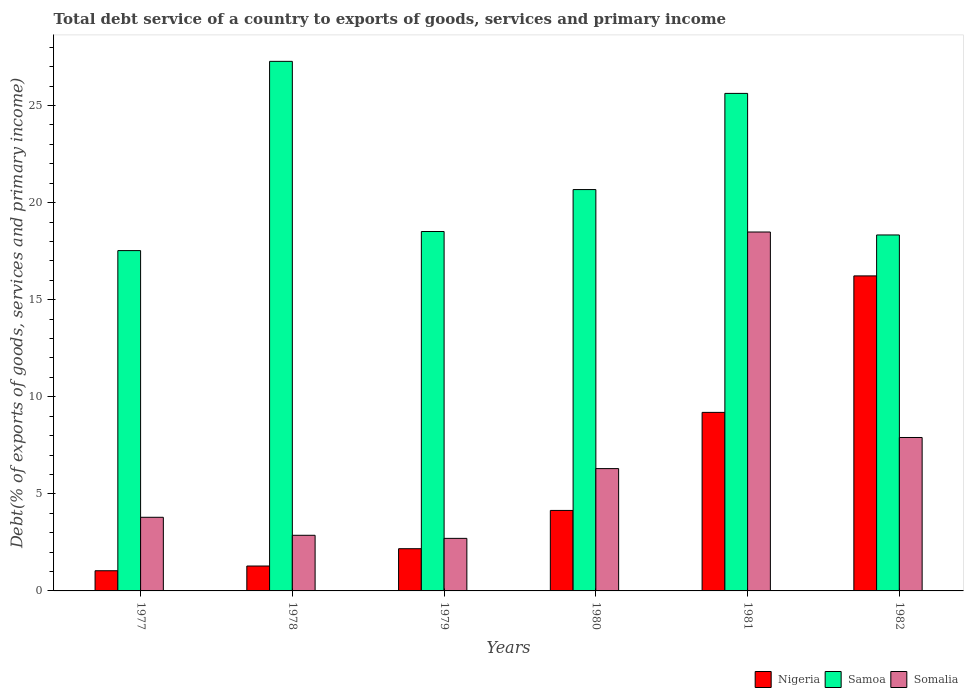How many groups of bars are there?
Provide a short and direct response. 6. Are the number of bars per tick equal to the number of legend labels?
Ensure brevity in your answer.  Yes. Are the number of bars on each tick of the X-axis equal?
Make the answer very short. Yes. How many bars are there on the 5th tick from the left?
Give a very brief answer. 3. How many bars are there on the 3rd tick from the right?
Your answer should be compact. 3. What is the total debt service in Samoa in 1979?
Ensure brevity in your answer.  18.51. Across all years, what is the maximum total debt service in Samoa?
Keep it short and to the point. 27.28. Across all years, what is the minimum total debt service in Nigeria?
Give a very brief answer. 1.04. In which year was the total debt service in Samoa maximum?
Offer a terse response. 1978. In which year was the total debt service in Nigeria minimum?
Your response must be concise. 1977. What is the total total debt service in Somalia in the graph?
Your answer should be very brief. 42.06. What is the difference between the total debt service in Somalia in 1977 and that in 1979?
Keep it short and to the point. 1.09. What is the difference between the total debt service in Nigeria in 1982 and the total debt service in Somalia in 1978?
Give a very brief answer. 13.36. What is the average total debt service in Nigeria per year?
Offer a terse response. 5.68. In the year 1982, what is the difference between the total debt service in Nigeria and total debt service in Somalia?
Your answer should be compact. 8.32. What is the ratio of the total debt service in Samoa in 1977 to that in 1978?
Make the answer very short. 0.64. Is the difference between the total debt service in Nigeria in 1977 and 1981 greater than the difference between the total debt service in Somalia in 1977 and 1981?
Provide a short and direct response. Yes. What is the difference between the highest and the second highest total debt service in Somalia?
Offer a terse response. 10.58. What is the difference between the highest and the lowest total debt service in Samoa?
Make the answer very short. 9.75. In how many years, is the total debt service in Nigeria greater than the average total debt service in Nigeria taken over all years?
Keep it short and to the point. 2. What does the 3rd bar from the left in 1982 represents?
Your response must be concise. Somalia. What does the 2nd bar from the right in 1981 represents?
Your answer should be very brief. Samoa. How many bars are there?
Keep it short and to the point. 18. Are all the bars in the graph horizontal?
Provide a short and direct response. No. How many years are there in the graph?
Provide a short and direct response. 6. What is the difference between two consecutive major ticks on the Y-axis?
Your response must be concise. 5. Does the graph contain grids?
Your response must be concise. No. What is the title of the graph?
Provide a short and direct response. Total debt service of a country to exports of goods, services and primary income. Does "Sweden" appear as one of the legend labels in the graph?
Give a very brief answer. No. What is the label or title of the Y-axis?
Provide a short and direct response. Debt(% of exports of goods, services and primary income). What is the Debt(% of exports of goods, services and primary income) in Nigeria in 1977?
Make the answer very short. 1.04. What is the Debt(% of exports of goods, services and primary income) of Samoa in 1977?
Give a very brief answer. 17.53. What is the Debt(% of exports of goods, services and primary income) of Somalia in 1977?
Ensure brevity in your answer.  3.79. What is the Debt(% of exports of goods, services and primary income) of Nigeria in 1978?
Give a very brief answer. 1.28. What is the Debt(% of exports of goods, services and primary income) in Samoa in 1978?
Your answer should be compact. 27.28. What is the Debt(% of exports of goods, services and primary income) of Somalia in 1978?
Provide a succinct answer. 2.87. What is the Debt(% of exports of goods, services and primary income) of Nigeria in 1979?
Your answer should be compact. 2.17. What is the Debt(% of exports of goods, services and primary income) of Samoa in 1979?
Give a very brief answer. 18.51. What is the Debt(% of exports of goods, services and primary income) in Somalia in 1979?
Make the answer very short. 2.71. What is the Debt(% of exports of goods, services and primary income) of Nigeria in 1980?
Give a very brief answer. 4.15. What is the Debt(% of exports of goods, services and primary income) of Samoa in 1980?
Your answer should be very brief. 20.67. What is the Debt(% of exports of goods, services and primary income) of Somalia in 1980?
Your answer should be compact. 6.3. What is the Debt(% of exports of goods, services and primary income) in Nigeria in 1981?
Your answer should be very brief. 9.2. What is the Debt(% of exports of goods, services and primary income) of Samoa in 1981?
Offer a terse response. 25.63. What is the Debt(% of exports of goods, services and primary income) in Somalia in 1981?
Provide a short and direct response. 18.49. What is the Debt(% of exports of goods, services and primary income) in Nigeria in 1982?
Your response must be concise. 16.23. What is the Debt(% of exports of goods, services and primary income) of Samoa in 1982?
Keep it short and to the point. 18.33. What is the Debt(% of exports of goods, services and primary income) in Somalia in 1982?
Make the answer very short. 7.9. Across all years, what is the maximum Debt(% of exports of goods, services and primary income) in Nigeria?
Give a very brief answer. 16.23. Across all years, what is the maximum Debt(% of exports of goods, services and primary income) of Samoa?
Your answer should be compact. 27.28. Across all years, what is the maximum Debt(% of exports of goods, services and primary income) in Somalia?
Offer a terse response. 18.49. Across all years, what is the minimum Debt(% of exports of goods, services and primary income) in Nigeria?
Offer a very short reply. 1.04. Across all years, what is the minimum Debt(% of exports of goods, services and primary income) in Samoa?
Keep it short and to the point. 17.53. Across all years, what is the minimum Debt(% of exports of goods, services and primary income) in Somalia?
Give a very brief answer. 2.71. What is the total Debt(% of exports of goods, services and primary income) in Nigeria in the graph?
Your answer should be compact. 34.06. What is the total Debt(% of exports of goods, services and primary income) of Samoa in the graph?
Make the answer very short. 127.95. What is the total Debt(% of exports of goods, services and primary income) in Somalia in the graph?
Your answer should be very brief. 42.06. What is the difference between the Debt(% of exports of goods, services and primary income) in Nigeria in 1977 and that in 1978?
Your response must be concise. -0.24. What is the difference between the Debt(% of exports of goods, services and primary income) of Samoa in 1977 and that in 1978?
Your answer should be compact. -9.75. What is the difference between the Debt(% of exports of goods, services and primary income) in Somalia in 1977 and that in 1978?
Give a very brief answer. 0.93. What is the difference between the Debt(% of exports of goods, services and primary income) in Nigeria in 1977 and that in 1979?
Your answer should be very brief. -1.13. What is the difference between the Debt(% of exports of goods, services and primary income) in Samoa in 1977 and that in 1979?
Offer a terse response. -0.98. What is the difference between the Debt(% of exports of goods, services and primary income) in Somalia in 1977 and that in 1979?
Your answer should be compact. 1.09. What is the difference between the Debt(% of exports of goods, services and primary income) in Nigeria in 1977 and that in 1980?
Provide a succinct answer. -3.11. What is the difference between the Debt(% of exports of goods, services and primary income) in Samoa in 1977 and that in 1980?
Provide a short and direct response. -3.14. What is the difference between the Debt(% of exports of goods, services and primary income) in Somalia in 1977 and that in 1980?
Provide a succinct answer. -2.51. What is the difference between the Debt(% of exports of goods, services and primary income) in Nigeria in 1977 and that in 1981?
Provide a succinct answer. -8.16. What is the difference between the Debt(% of exports of goods, services and primary income) in Samoa in 1977 and that in 1981?
Provide a short and direct response. -8.1. What is the difference between the Debt(% of exports of goods, services and primary income) in Somalia in 1977 and that in 1981?
Your answer should be very brief. -14.69. What is the difference between the Debt(% of exports of goods, services and primary income) of Nigeria in 1977 and that in 1982?
Offer a terse response. -15.19. What is the difference between the Debt(% of exports of goods, services and primary income) of Samoa in 1977 and that in 1982?
Provide a succinct answer. -0.81. What is the difference between the Debt(% of exports of goods, services and primary income) of Somalia in 1977 and that in 1982?
Ensure brevity in your answer.  -4.11. What is the difference between the Debt(% of exports of goods, services and primary income) in Nigeria in 1978 and that in 1979?
Make the answer very short. -0.89. What is the difference between the Debt(% of exports of goods, services and primary income) of Samoa in 1978 and that in 1979?
Keep it short and to the point. 8.76. What is the difference between the Debt(% of exports of goods, services and primary income) in Somalia in 1978 and that in 1979?
Provide a succinct answer. 0.16. What is the difference between the Debt(% of exports of goods, services and primary income) in Nigeria in 1978 and that in 1980?
Keep it short and to the point. -2.86. What is the difference between the Debt(% of exports of goods, services and primary income) in Samoa in 1978 and that in 1980?
Keep it short and to the point. 6.6. What is the difference between the Debt(% of exports of goods, services and primary income) of Somalia in 1978 and that in 1980?
Make the answer very short. -3.43. What is the difference between the Debt(% of exports of goods, services and primary income) in Nigeria in 1978 and that in 1981?
Your answer should be very brief. -7.91. What is the difference between the Debt(% of exports of goods, services and primary income) of Samoa in 1978 and that in 1981?
Your answer should be compact. 1.65. What is the difference between the Debt(% of exports of goods, services and primary income) in Somalia in 1978 and that in 1981?
Provide a succinct answer. -15.62. What is the difference between the Debt(% of exports of goods, services and primary income) of Nigeria in 1978 and that in 1982?
Your answer should be very brief. -14.94. What is the difference between the Debt(% of exports of goods, services and primary income) of Samoa in 1978 and that in 1982?
Offer a very short reply. 8.94. What is the difference between the Debt(% of exports of goods, services and primary income) of Somalia in 1978 and that in 1982?
Your answer should be compact. -5.04. What is the difference between the Debt(% of exports of goods, services and primary income) of Nigeria in 1979 and that in 1980?
Your answer should be compact. -1.97. What is the difference between the Debt(% of exports of goods, services and primary income) in Samoa in 1979 and that in 1980?
Your response must be concise. -2.16. What is the difference between the Debt(% of exports of goods, services and primary income) in Somalia in 1979 and that in 1980?
Offer a terse response. -3.59. What is the difference between the Debt(% of exports of goods, services and primary income) of Nigeria in 1979 and that in 1981?
Your response must be concise. -7.02. What is the difference between the Debt(% of exports of goods, services and primary income) in Samoa in 1979 and that in 1981?
Offer a terse response. -7.11. What is the difference between the Debt(% of exports of goods, services and primary income) of Somalia in 1979 and that in 1981?
Provide a short and direct response. -15.78. What is the difference between the Debt(% of exports of goods, services and primary income) in Nigeria in 1979 and that in 1982?
Make the answer very short. -14.05. What is the difference between the Debt(% of exports of goods, services and primary income) in Samoa in 1979 and that in 1982?
Offer a very short reply. 0.18. What is the difference between the Debt(% of exports of goods, services and primary income) of Somalia in 1979 and that in 1982?
Your answer should be compact. -5.2. What is the difference between the Debt(% of exports of goods, services and primary income) in Nigeria in 1980 and that in 1981?
Keep it short and to the point. -5.05. What is the difference between the Debt(% of exports of goods, services and primary income) in Samoa in 1980 and that in 1981?
Your answer should be compact. -4.95. What is the difference between the Debt(% of exports of goods, services and primary income) in Somalia in 1980 and that in 1981?
Provide a short and direct response. -12.19. What is the difference between the Debt(% of exports of goods, services and primary income) in Nigeria in 1980 and that in 1982?
Your answer should be compact. -12.08. What is the difference between the Debt(% of exports of goods, services and primary income) in Samoa in 1980 and that in 1982?
Make the answer very short. 2.34. What is the difference between the Debt(% of exports of goods, services and primary income) in Somalia in 1980 and that in 1982?
Keep it short and to the point. -1.6. What is the difference between the Debt(% of exports of goods, services and primary income) in Nigeria in 1981 and that in 1982?
Your answer should be very brief. -7.03. What is the difference between the Debt(% of exports of goods, services and primary income) of Samoa in 1981 and that in 1982?
Your response must be concise. 7.29. What is the difference between the Debt(% of exports of goods, services and primary income) of Somalia in 1981 and that in 1982?
Offer a very short reply. 10.58. What is the difference between the Debt(% of exports of goods, services and primary income) of Nigeria in 1977 and the Debt(% of exports of goods, services and primary income) of Samoa in 1978?
Offer a terse response. -26.24. What is the difference between the Debt(% of exports of goods, services and primary income) in Nigeria in 1977 and the Debt(% of exports of goods, services and primary income) in Somalia in 1978?
Provide a short and direct response. -1.83. What is the difference between the Debt(% of exports of goods, services and primary income) in Samoa in 1977 and the Debt(% of exports of goods, services and primary income) in Somalia in 1978?
Give a very brief answer. 14.66. What is the difference between the Debt(% of exports of goods, services and primary income) of Nigeria in 1977 and the Debt(% of exports of goods, services and primary income) of Samoa in 1979?
Give a very brief answer. -17.47. What is the difference between the Debt(% of exports of goods, services and primary income) of Nigeria in 1977 and the Debt(% of exports of goods, services and primary income) of Somalia in 1979?
Offer a very short reply. -1.67. What is the difference between the Debt(% of exports of goods, services and primary income) in Samoa in 1977 and the Debt(% of exports of goods, services and primary income) in Somalia in 1979?
Make the answer very short. 14.82. What is the difference between the Debt(% of exports of goods, services and primary income) of Nigeria in 1977 and the Debt(% of exports of goods, services and primary income) of Samoa in 1980?
Your response must be concise. -19.63. What is the difference between the Debt(% of exports of goods, services and primary income) in Nigeria in 1977 and the Debt(% of exports of goods, services and primary income) in Somalia in 1980?
Give a very brief answer. -5.26. What is the difference between the Debt(% of exports of goods, services and primary income) in Samoa in 1977 and the Debt(% of exports of goods, services and primary income) in Somalia in 1980?
Your response must be concise. 11.23. What is the difference between the Debt(% of exports of goods, services and primary income) of Nigeria in 1977 and the Debt(% of exports of goods, services and primary income) of Samoa in 1981?
Provide a short and direct response. -24.59. What is the difference between the Debt(% of exports of goods, services and primary income) in Nigeria in 1977 and the Debt(% of exports of goods, services and primary income) in Somalia in 1981?
Give a very brief answer. -17.45. What is the difference between the Debt(% of exports of goods, services and primary income) of Samoa in 1977 and the Debt(% of exports of goods, services and primary income) of Somalia in 1981?
Provide a short and direct response. -0.96. What is the difference between the Debt(% of exports of goods, services and primary income) of Nigeria in 1977 and the Debt(% of exports of goods, services and primary income) of Samoa in 1982?
Ensure brevity in your answer.  -17.3. What is the difference between the Debt(% of exports of goods, services and primary income) in Nigeria in 1977 and the Debt(% of exports of goods, services and primary income) in Somalia in 1982?
Provide a short and direct response. -6.86. What is the difference between the Debt(% of exports of goods, services and primary income) in Samoa in 1977 and the Debt(% of exports of goods, services and primary income) in Somalia in 1982?
Your answer should be compact. 9.63. What is the difference between the Debt(% of exports of goods, services and primary income) of Nigeria in 1978 and the Debt(% of exports of goods, services and primary income) of Samoa in 1979?
Offer a very short reply. -17.23. What is the difference between the Debt(% of exports of goods, services and primary income) in Nigeria in 1978 and the Debt(% of exports of goods, services and primary income) in Somalia in 1979?
Provide a short and direct response. -1.42. What is the difference between the Debt(% of exports of goods, services and primary income) of Samoa in 1978 and the Debt(% of exports of goods, services and primary income) of Somalia in 1979?
Make the answer very short. 24.57. What is the difference between the Debt(% of exports of goods, services and primary income) in Nigeria in 1978 and the Debt(% of exports of goods, services and primary income) in Samoa in 1980?
Offer a terse response. -19.39. What is the difference between the Debt(% of exports of goods, services and primary income) in Nigeria in 1978 and the Debt(% of exports of goods, services and primary income) in Somalia in 1980?
Provide a short and direct response. -5.02. What is the difference between the Debt(% of exports of goods, services and primary income) in Samoa in 1978 and the Debt(% of exports of goods, services and primary income) in Somalia in 1980?
Offer a terse response. 20.98. What is the difference between the Debt(% of exports of goods, services and primary income) in Nigeria in 1978 and the Debt(% of exports of goods, services and primary income) in Samoa in 1981?
Ensure brevity in your answer.  -24.34. What is the difference between the Debt(% of exports of goods, services and primary income) in Nigeria in 1978 and the Debt(% of exports of goods, services and primary income) in Somalia in 1981?
Give a very brief answer. -17.2. What is the difference between the Debt(% of exports of goods, services and primary income) in Samoa in 1978 and the Debt(% of exports of goods, services and primary income) in Somalia in 1981?
Your response must be concise. 8.79. What is the difference between the Debt(% of exports of goods, services and primary income) of Nigeria in 1978 and the Debt(% of exports of goods, services and primary income) of Samoa in 1982?
Your answer should be very brief. -17.05. What is the difference between the Debt(% of exports of goods, services and primary income) in Nigeria in 1978 and the Debt(% of exports of goods, services and primary income) in Somalia in 1982?
Keep it short and to the point. -6.62. What is the difference between the Debt(% of exports of goods, services and primary income) in Samoa in 1978 and the Debt(% of exports of goods, services and primary income) in Somalia in 1982?
Your answer should be very brief. 19.37. What is the difference between the Debt(% of exports of goods, services and primary income) of Nigeria in 1979 and the Debt(% of exports of goods, services and primary income) of Samoa in 1980?
Offer a very short reply. -18.5. What is the difference between the Debt(% of exports of goods, services and primary income) in Nigeria in 1979 and the Debt(% of exports of goods, services and primary income) in Somalia in 1980?
Give a very brief answer. -4.13. What is the difference between the Debt(% of exports of goods, services and primary income) in Samoa in 1979 and the Debt(% of exports of goods, services and primary income) in Somalia in 1980?
Ensure brevity in your answer.  12.21. What is the difference between the Debt(% of exports of goods, services and primary income) in Nigeria in 1979 and the Debt(% of exports of goods, services and primary income) in Samoa in 1981?
Offer a terse response. -23.45. What is the difference between the Debt(% of exports of goods, services and primary income) in Nigeria in 1979 and the Debt(% of exports of goods, services and primary income) in Somalia in 1981?
Give a very brief answer. -16.31. What is the difference between the Debt(% of exports of goods, services and primary income) in Samoa in 1979 and the Debt(% of exports of goods, services and primary income) in Somalia in 1981?
Give a very brief answer. 0.03. What is the difference between the Debt(% of exports of goods, services and primary income) in Nigeria in 1979 and the Debt(% of exports of goods, services and primary income) in Samoa in 1982?
Your response must be concise. -16.16. What is the difference between the Debt(% of exports of goods, services and primary income) in Nigeria in 1979 and the Debt(% of exports of goods, services and primary income) in Somalia in 1982?
Keep it short and to the point. -5.73. What is the difference between the Debt(% of exports of goods, services and primary income) in Samoa in 1979 and the Debt(% of exports of goods, services and primary income) in Somalia in 1982?
Your answer should be compact. 10.61. What is the difference between the Debt(% of exports of goods, services and primary income) of Nigeria in 1980 and the Debt(% of exports of goods, services and primary income) of Samoa in 1981?
Your response must be concise. -21.48. What is the difference between the Debt(% of exports of goods, services and primary income) of Nigeria in 1980 and the Debt(% of exports of goods, services and primary income) of Somalia in 1981?
Provide a succinct answer. -14.34. What is the difference between the Debt(% of exports of goods, services and primary income) of Samoa in 1980 and the Debt(% of exports of goods, services and primary income) of Somalia in 1981?
Ensure brevity in your answer.  2.19. What is the difference between the Debt(% of exports of goods, services and primary income) in Nigeria in 1980 and the Debt(% of exports of goods, services and primary income) in Samoa in 1982?
Offer a terse response. -14.19. What is the difference between the Debt(% of exports of goods, services and primary income) in Nigeria in 1980 and the Debt(% of exports of goods, services and primary income) in Somalia in 1982?
Give a very brief answer. -3.76. What is the difference between the Debt(% of exports of goods, services and primary income) of Samoa in 1980 and the Debt(% of exports of goods, services and primary income) of Somalia in 1982?
Your answer should be very brief. 12.77. What is the difference between the Debt(% of exports of goods, services and primary income) in Nigeria in 1981 and the Debt(% of exports of goods, services and primary income) in Samoa in 1982?
Your answer should be compact. -9.14. What is the difference between the Debt(% of exports of goods, services and primary income) of Nigeria in 1981 and the Debt(% of exports of goods, services and primary income) of Somalia in 1982?
Your answer should be compact. 1.29. What is the difference between the Debt(% of exports of goods, services and primary income) of Samoa in 1981 and the Debt(% of exports of goods, services and primary income) of Somalia in 1982?
Your answer should be very brief. 17.72. What is the average Debt(% of exports of goods, services and primary income) in Nigeria per year?
Provide a short and direct response. 5.68. What is the average Debt(% of exports of goods, services and primary income) in Samoa per year?
Your response must be concise. 21.33. What is the average Debt(% of exports of goods, services and primary income) of Somalia per year?
Offer a terse response. 7.01. In the year 1977, what is the difference between the Debt(% of exports of goods, services and primary income) of Nigeria and Debt(% of exports of goods, services and primary income) of Samoa?
Offer a very short reply. -16.49. In the year 1977, what is the difference between the Debt(% of exports of goods, services and primary income) in Nigeria and Debt(% of exports of goods, services and primary income) in Somalia?
Your response must be concise. -2.75. In the year 1977, what is the difference between the Debt(% of exports of goods, services and primary income) of Samoa and Debt(% of exports of goods, services and primary income) of Somalia?
Your answer should be very brief. 13.74. In the year 1978, what is the difference between the Debt(% of exports of goods, services and primary income) in Nigeria and Debt(% of exports of goods, services and primary income) in Samoa?
Offer a very short reply. -25.99. In the year 1978, what is the difference between the Debt(% of exports of goods, services and primary income) in Nigeria and Debt(% of exports of goods, services and primary income) in Somalia?
Offer a very short reply. -1.58. In the year 1978, what is the difference between the Debt(% of exports of goods, services and primary income) in Samoa and Debt(% of exports of goods, services and primary income) in Somalia?
Make the answer very short. 24.41. In the year 1979, what is the difference between the Debt(% of exports of goods, services and primary income) in Nigeria and Debt(% of exports of goods, services and primary income) in Samoa?
Offer a terse response. -16.34. In the year 1979, what is the difference between the Debt(% of exports of goods, services and primary income) in Nigeria and Debt(% of exports of goods, services and primary income) in Somalia?
Keep it short and to the point. -0.53. In the year 1979, what is the difference between the Debt(% of exports of goods, services and primary income) in Samoa and Debt(% of exports of goods, services and primary income) in Somalia?
Provide a succinct answer. 15.81. In the year 1980, what is the difference between the Debt(% of exports of goods, services and primary income) in Nigeria and Debt(% of exports of goods, services and primary income) in Samoa?
Provide a short and direct response. -16.53. In the year 1980, what is the difference between the Debt(% of exports of goods, services and primary income) of Nigeria and Debt(% of exports of goods, services and primary income) of Somalia?
Ensure brevity in your answer.  -2.15. In the year 1980, what is the difference between the Debt(% of exports of goods, services and primary income) of Samoa and Debt(% of exports of goods, services and primary income) of Somalia?
Your response must be concise. 14.37. In the year 1981, what is the difference between the Debt(% of exports of goods, services and primary income) of Nigeria and Debt(% of exports of goods, services and primary income) of Samoa?
Give a very brief answer. -16.43. In the year 1981, what is the difference between the Debt(% of exports of goods, services and primary income) in Nigeria and Debt(% of exports of goods, services and primary income) in Somalia?
Your answer should be very brief. -9.29. In the year 1981, what is the difference between the Debt(% of exports of goods, services and primary income) in Samoa and Debt(% of exports of goods, services and primary income) in Somalia?
Give a very brief answer. 7.14. In the year 1982, what is the difference between the Debt(% of exports of goods, services and primary income) in Nigeria and Debt(% of exports of goods, services and primary income) in Samoa?
Keep it short and to the point. -2.11. In the year 1982, what is the difference between the Debt(% of exports of goods, services and primary income) in Nigeria and Debt(% of exports of goods, services and primary income) in Somalia?
Keep it short and to the point. 8.32. In the year 1982, what is the difference between the Debt(% of exports of goods, services and primary income) of Samoa and Debt(% of exports of goods, services and primary income) of Somalia?
Give a very brief answer. 10.43. What is the ratio of the Debt(% of exports of goods, services and primary income) in Nigeria in 1977 to that in 1978?
Your response must be concise. 0.81. What is the ratio of the Debt(% of exports of goods, services and primary income) in Samoa in 1977 to that in 1978?
Your answer should be compact. 0.64. What is the ratio of the Debt(% of exports of goods, services and primary income) in Somalia in 1977 to that in 1978?
Provide a succinct answer. 1.32. What is the ratio of the Debt(% of exports of goods, services and primary income) in Nigeria in 1977 to that in 1979?
Provide a succinct answer. 0.48. What is the ratio of the Debt(% of exports of goods, services and primary income) of Samoa in 1977 to that in 1979?
Your response must be concise. 0.95. What is the ratio of the Debt(% of exports of goods, services and primary income) of Somalia in 1977 to that in 1979?
Your answer should be compact. 1.4. What is the ratio of the Debt(% of exports of goods, services and primary income) in Nigeria in 1977 to that in 1980?
Make the answer very short. 0.25. What is the ratio of the Debt(% of exports of goods, services and primary income) of Samoa in 1977 to that in 1980?
Provide a short and direct response. 0.85. What is the ratio of the Debt(% of exports of goods, services and primary income) of Somalia in 1977 to that in 1980?
Your response must be concise. 0.6. What is the ratio of the Debt(% of exports of goods, services and primary income) in Nigeria in 1977 to that in 1981?
Offer a very short reply. 0.11. What is the ratio of the Debt(% of exports of goods, services and primary income) in Samoa in 1977 to that in 1981?
Your answer should be very brief. 0.68. What is the ratio of the Debt(% of exports of goods, services and primary income) of Somalia in 1977 to that in 1981?
Make the answer very short. 0.21. What is the ratio of the Debt(% of exports of goods, services and primary income) in Nigeria in 1977 to that in 1982?
Provide a succinct answer. 0.06. What is the ratio of the Debt(% of exports of goods, services and primary income) of Samoa in 1977 to that in 1982?
Your answer should be very brief. 0.96. What is the ratio of the Debt(% of exports of goods, services and primary income) of Somalia in 1977 to that in 1982?
Give a very brief answer. 0.48. What is the ratio of the Debt(% of exports of goods, services and primary income) in Nigeria in 1978 to that in 1979?
Keep it short and to the point. 0.59. What is the ratio of the Debt(% of exports of goods, services and primary income) in Samoa in 1978 to that in 1979?
Keep it short and to the point. 1.47. What is the ratio of the Debt(% of exports of goods, services and primary income) of Somalia in 1978 to that in 1979?
Your answer should be compact. 1.06. What is the ratio of the Debt(% of exports of goods, services and primary income) in Nigeria in 1978 to that in 1980?
Give a very brief answer. 0.31. What is the ratio of the Debt(% of exports of goods, services and primary income) of Samoa in 1978 to that in 1980?
Your response must be concise. 1.32. What is the ratio of the Debt(% of exports of goods, services and primary income) of Somalia in 1978 to that in 1980?
Your answer should be very brief. 0.45. What is the ratio of the Debt(% of exports of goods, services and primary income) in Nigeria in 1978 to that in 1981?
Your answer should be very brief. 0.14. What is the ratio of the Debt(% of exports of goods, services and primary income) in Samoa in 1978 to that in 1981?
Your answer should be very brief. 1.06. What is the ratio of the Debt(% of exports of goods, services and primary income) in Somalia in 1978 to that in 1981?
Your answer should be compact. 0.15. What is the ratio of the Debt(% of exports of goods, services and primary income) of Nigeria in 1978 to that in 1982?
Provide a succinct answer. 0.08. What is the ratio of the Debt(% of exports of goods, services and primary income) of Samoa in 1978 to that in 1982?
Give a very brief answer. 1.49. What is the ratio of the Debt(% of exports of goods, services and primary income) of Somalia in 1978 to that in 1982?
Give a very brief answer. 0.36. What is the ratio of the Debt(% of exports of goods, services and primary income) of Nigeria in 1979 to that in 1980?
Provide a short and direct response. 0.52. What is the ratio of the Debt(% of exports of goods, services and primary income) of Samoa in 1979 to that in 1980?
Keep it short and to the point. 0.9. What is the ratio of the Debt(% of exports of goods, services and primary income) of Somalia in 1979 to that in 1980?
Provide a succinct answer. 0.43. What is the ratio of the Debt(% of exports of goods, services and primary income) of Nigeria in 1979 to that in 1981?
Give a very brief answer. 0.24. What is the ratio of the Debt(% of exports of goods, services and primary income) of Samoa in 1979 to that in 1981?
Offer a very short reply. 0.72. What is the ratio of the Debt(% of exports of goods, services and primary income) in Somalia in 1979 to that in 1981?
Make the answer very short. 0.15. What is the ratio of the Debt(% of exports of goods, services and primary income) in Nigeria in 1979 to that in 1982?
Offer a terse response. 0.13. What is the ratio of the Debt(% of exports of goods, services and primary income) in Samoa in 1979 to that in 1982?
Provide a short and direct response. 1.01. What is the ratio of the Debt(% of exports of goods, services and primary income) in Somalia in 1979 to that in 1982?
Your answer should be compact. 0.34. What is the ratio of the Debt(% of exports of goods, services and primary income) of Nigeria in 1980 to that in 1981?
Offer a very short reply. 0.45. What is the ratio of the Debt(% of exports of goods, services and primary income) in Samoa in 1980 to that in 1981?
Your answer should be very brief. 0.81. What is the ratio of the Debt(% of exports of goods, services and primary income) of Somalia in 1980 to that in 1981?
Provide a succinct answer. 0.34. What is the ratio of the Debt(% of exports of goods, services and primary income) of Nigeria in 1980 to that in 1982?
Make the answer very short. 0.26. What is the ratio of the Debt(% of exports of goods, services and primary income) in Samoa in 1980 to that in 1982?
Provide a short and direct response. 1.13. What is the ratio of the Debt(% of exports of goods, services and primary income) in Somalia in 1980 to that in 1982?
Offer a very short reply. 0.8. What is the ratio of the Debt(% of exports of goods, services and primary income) of Nigeria in 1981 to that in 1982?
Keep it short and to the point. 0.57. What is the ratio of the Debt(% of exports of goods, services and primary income) of Samoa in 1981 to that in 1982?
Provide a succinct answer. 1.4. What is the ratio of the Debt(% of exports of goods, services and primary income) in Somalia in 1981 to that in 1982?
Give a very brief answer. 2.34. What is the difference between the highest and the second highest Debt(% of exports of goods, services and primary income) of Nigeria?
Make the answer very short. 7.03. What is the difference between the highest and the second highest Debt(% of exports of goods, services and primary income) of Samoa?
Your response must be concise. 1.65. What is the difference between the highest and the second highest Debt(% of exports of goods, services and primary income) in Somalia?
Your answer should be very brief. 10.58. What is the difference between the highest and the lowest Debt(% of exports of goods, services and primary income) of Nigeria?
Provide a short and direct response. 15.19. What is the difference between the highest and the lowest Debt(% of exports of goods, services and primary income) of Samoa?
Offer a terse response. 9.75. What is the difference between the highest and the lowest Debt(% of exports of goods, services and primary income) in Somalia?
Offer a very short reply. 15.78. 